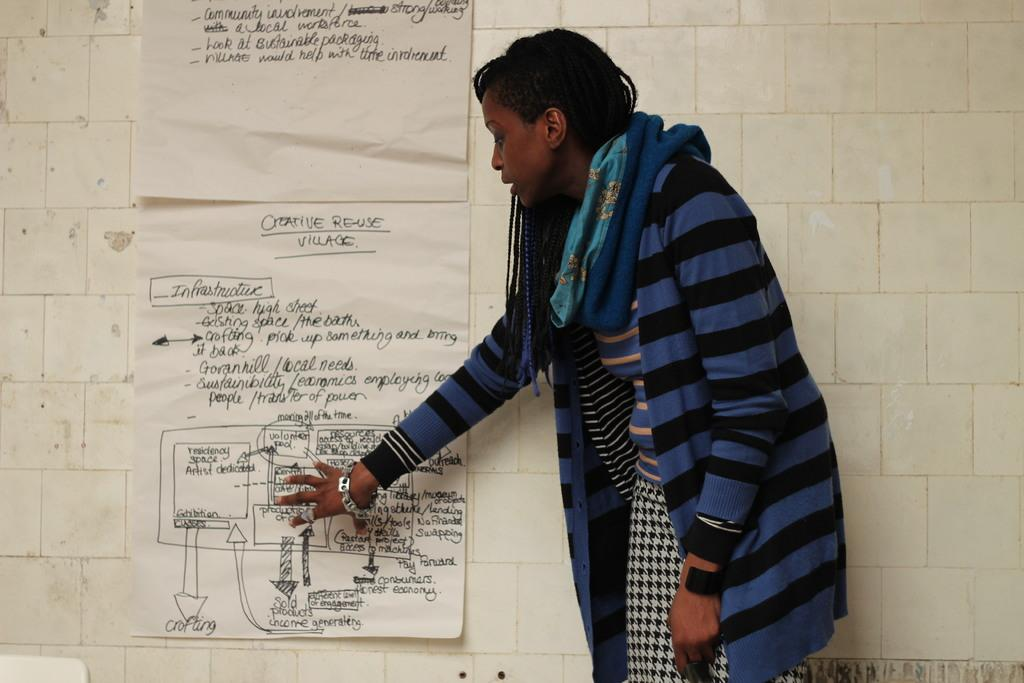Who is present in the image? There is a woman in the image. What is the woman wearing? The woman is wearing a multi-color dress. Where is the woman located in the image? The woman is standing near a wall. What can be seen on the wall? There are papers attached to the wall, and words are written on them. What type of camera is the woman holding in the image? There is no camera present in the image. 